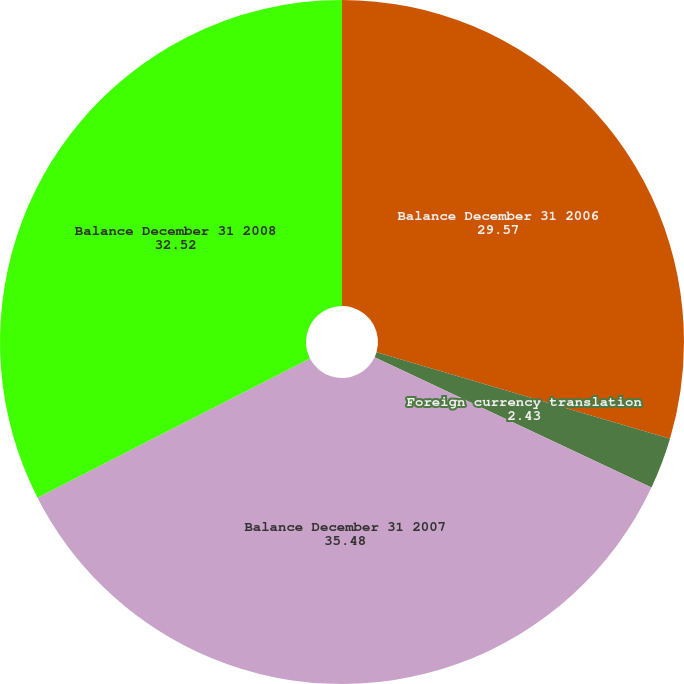<chart> <loc_0><loc_0><loc_500><loc_500><pie_chart><fcel>Balance December 31 2006<fcel>Foreign currency translation<fcel>Balance December 31 2007<fcel>Balance December 31 2008<nl><fcel>29.57%<fcel>2.43%<fcel>35.48%<fcel>32.52%<nl></chart> 